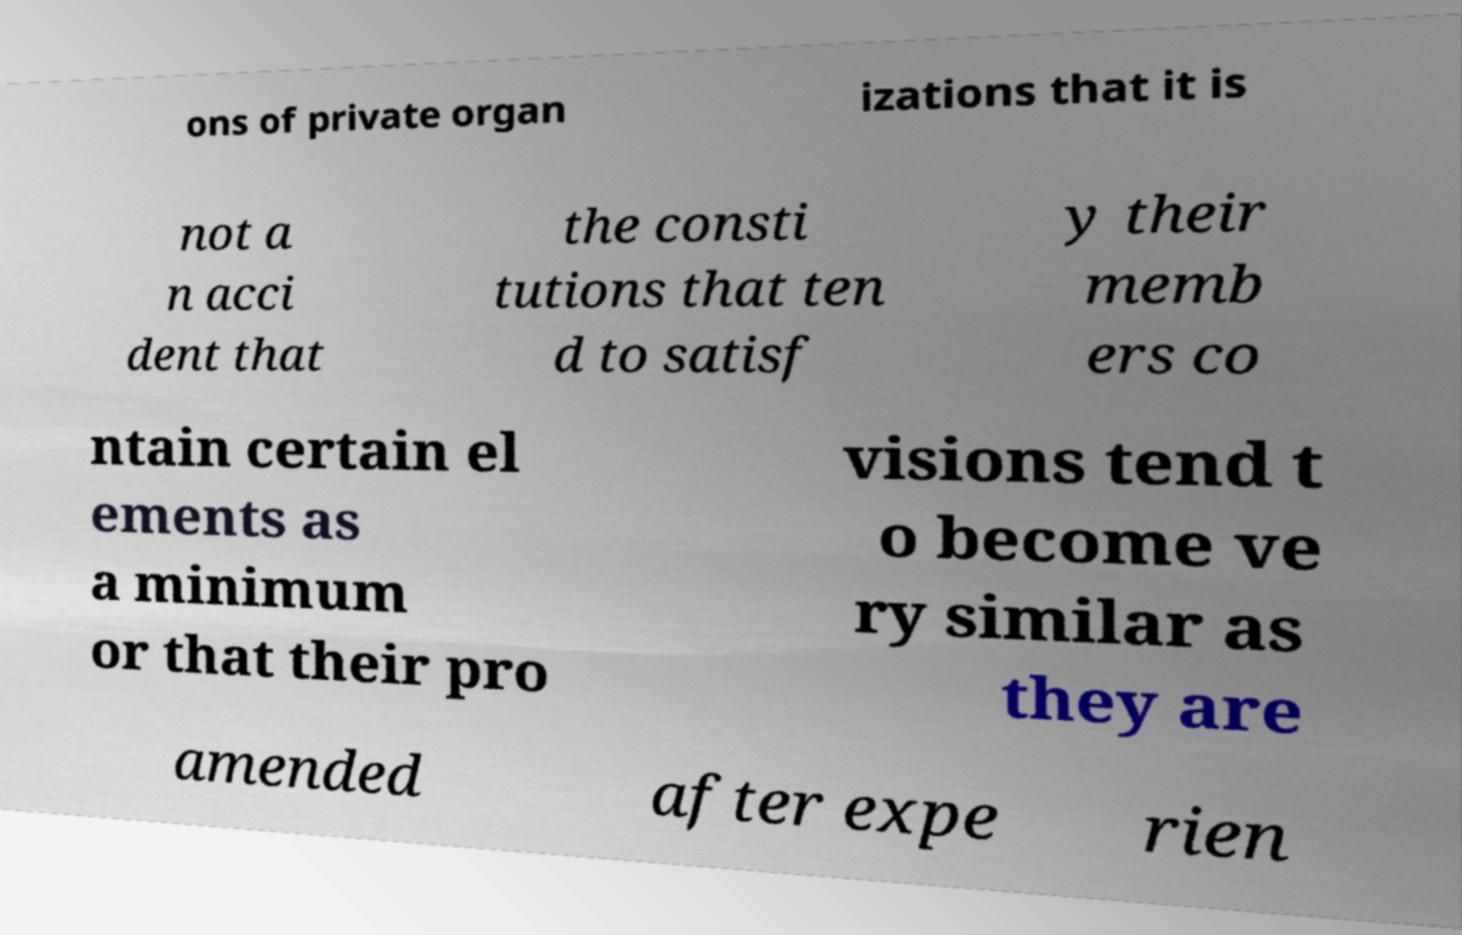Could you extract and type out the text from this image? ons of private organ izations that it is not a n acci dent that the consti tutions that ten d to satisf y their memb ers co ntain certain el ements as a minimum or that their pro visions tend t o become ve ry similar as they are amended after expe rien 